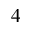<formula> <loc_0><loc_0><loc_500><loc_500>_ { 4 }</formula> 